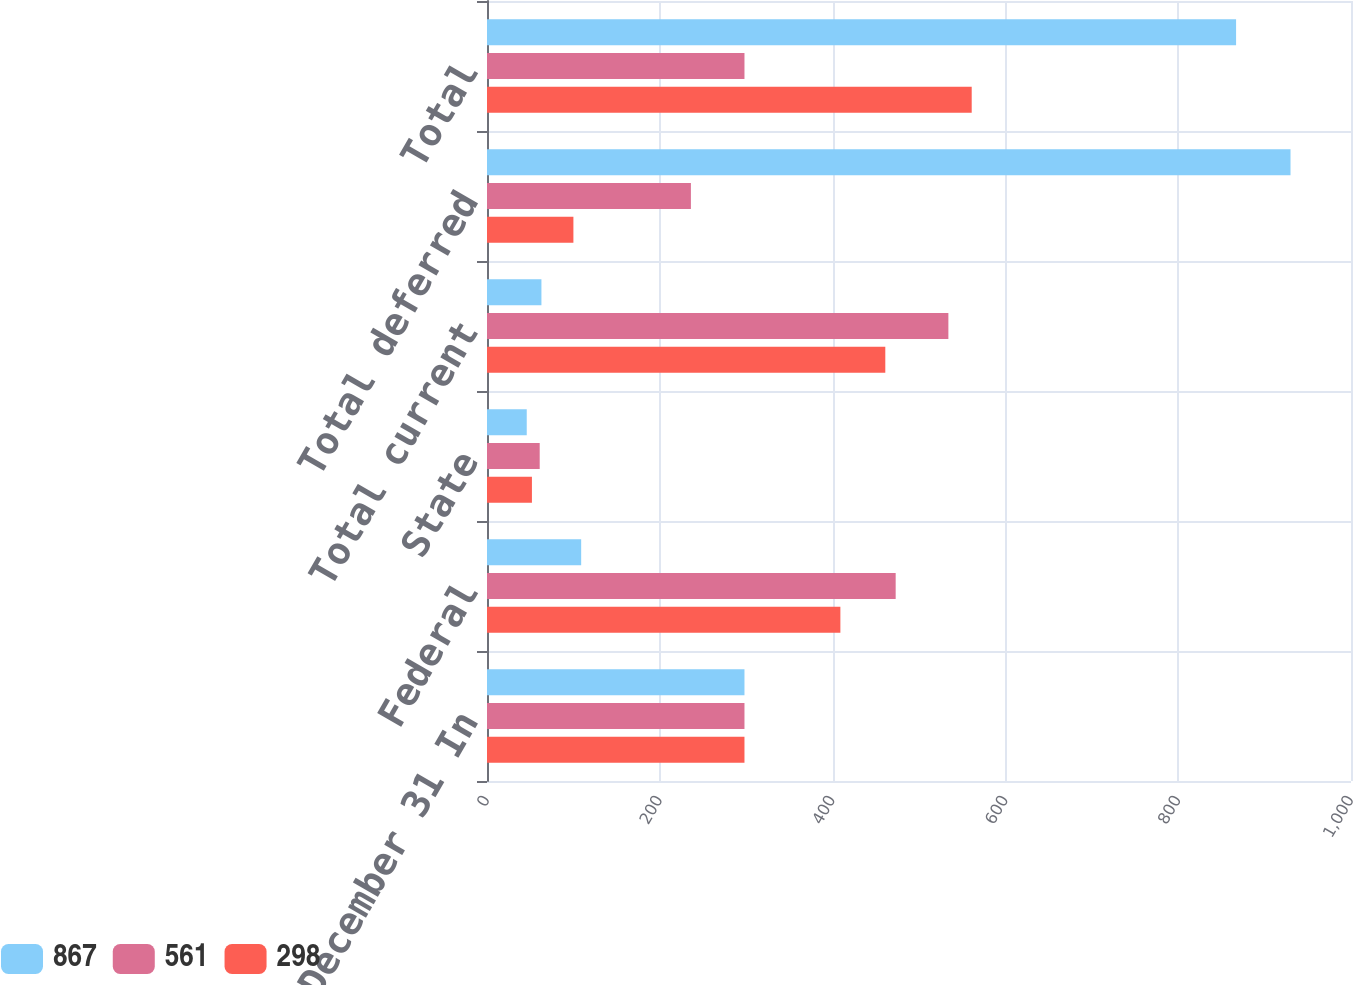Convert chart. <chart><loc_0><loc_0><loc_500><loc_500><stacked_bar_chart><ecel><fcel>Year ended December 31 In<fcel>Federal<fcel>State<fcel>Total current<fcel>Total deferred<fcel>Total<nl><fcel>867<fcel>298<fcel>109<fcel>46<fcel>63<fcel>930<fcel>867<nl><fcel>561<fcel>298<fcel>473<fcel>61<fcel>534<fcel>236<fcel>298<nl><fcel>298<fcel>298<fcel>409<fcel>52<fcel>461<fcel>100<fcel>561<nl></chart> 